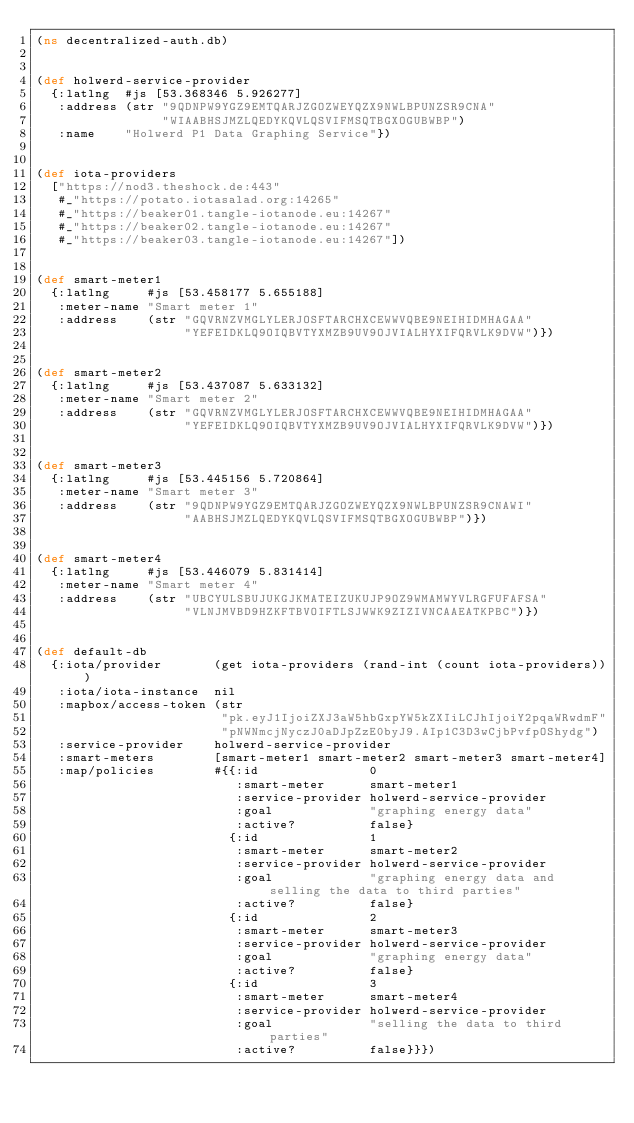<code> <loc_0><loc_0><loc_500><loc_500><_Clojure_>(ns decentralized-auth.db)


(def holwerd-service-provider
  {:latlng  #js [53.368346 5.926277]
   :address (str "9QDNPW9YGZ9EMTQARJZGOZWEYQZX9NWLBPUNZSR9CNA"
                 "WIAABHSJMZLQEDYKQVLQSVIFMSQTBGXOGUBWBP")
   :name    "Holwerd P1 Data Graphing Service"})


(def iota-providers
  ["https://nod3.theshock.de:443"
   #_"https://potato.iotasalad.org:14265"
   #_"https://beaker01.tangle-iotanode.eu:14267"
   #_"https://beaker02.tangle-iotanode.eu:14267"
   #_"https://beaker03.tangle-iotanode.eu:14267"])


(def smart-meter1
  {:latlng     #js [53.458177 5.655188]
   :meter-name "Smart meter 1"
   :address    (str "GQVRNZVMGLYLERJOSFTARCHXCEWWVQBE9NEIHIDMHAGAA"
                    "YEFEIDKLQ9OIQBVTYXMZB9UV9OJVIALHYXIFQRVLK9DVW")})


(def smart-meter2
  {:latlng     #js [53.437087 5.633132]
   :meter-name "Smart meter 2"
   :address    (str "GQVRNZVMGLYLERJOSFTARCHXCEWWVQBE9NEIHIDMHAGAA"
                    "YEFEIDKLQ9OIQBVTYXMZB9UV9OJVIALHYXIFQRVLK9DVW")})


(def smart-meter3
  {:latlng     #js [53.445156 5.720864]
   :meter-name "Smart meter 3"
   :address    (str "9QDNPW9YGZ9EMTQARJZGOZWEYQZX9NWLBPUNZSR9CNAWI"
                    "AABHSJMZLQEDYKQVLQSVIFMSQTBGXOGUBWBP")})


(def smart-meter4
  {:latlng     #js [53.446079 5.831414]
   :meter-name "Smart meter 4"
   :address    (str "UBCYULSBUJUKGJKMATEIZUKUJP9OZ9WMAMWYVLRGFUFAFSA"
                    "VLNJMVBD9HZKFTBVOIFTLSJWWK9ZIZIVNCAAEATKPBC")})


(def default-db
  {:iota/provider       (get iota-providers (rand-int (count iota-providers)))
   :iota/iota-instance  nil
   :mapbox/access-token (str
                         "pk.eyJ1IjoiZXJ3aW5hbGxpYW5kZXIiLCJhIjoiY2pqaWRwdmF"
                         "pNWNmcjNyczJ0aDJpZzE0byJ9.AIp1C3D3wCjbPvfpOShydg")
   :service-provider    holwerd-service-provider
   :smart-meters        [smart-meter1 smart-meter2 smart-meter3 smart-meter4]
   :map/policies        #{{:id               0
                           :smart-meter      smart-meter1
                           :service-provider holwerd-service-provider
                           :goal             "graphing energy data"
                           :active?          false}
                          {:id               1
                           :smart-meter      smart-meter2
                           :service-provider holwerd-service-provider
                           :goal             "graphing energy data and selling the data to third parties"
                           :active?          false}
                          {:id               2
                           :smart-meter      smart-meter3
                           :service-provider holwerd-service-provider
                           :goal             "graphing energy data"
                           :active?          false}
                          {:id               3
                           :smart-meter      smart-meter4
                           :service-provider holwerd-service-provider
                           :goal             "selling the data to third parties"
                           :active?          false}}})
</code> 